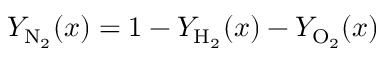<formula> <loc_0><loc_0><loc_500><loc_500>Y _ { N _ { 2 } } ( x ) = 1 - Y _ { H _ { 2 } } ( x ) - Y _ { O _ { 2 } } ( x )</formula> 